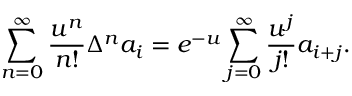Convert formula to latex. <formula><loc_0><loc_0><loc_500><loc_500>\sum _ { n = 0 } ^ { \infty } { \frac { u ^ { n } } { n ! } } \Delta ^ { n } a _ { i } = e ^ { - u } \sum _ { j = 0 } ^ { \infty } { \frac { u ^ { j } } { j ! } } a _ { i + j } .</formula> 